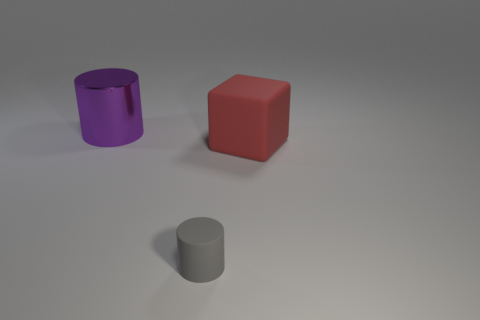Is there any other thing that is the same size as the gray cylinder?
Ensure brevity in your answer.  No. Is there anything else that is the same material as the purple object?
Give a very brief answer. No. What is the shape of the purple metal thing?
Your answer should be compact. Cylinder. Are there any other things that are the same shape as the tiny rubber object?
Your answer should be very brief. Yes. Is the number of small gray rubber cylinders that are on the right side of the large rubber cube less than the number of large yellow balls?
Provide a short and direct response. No. There is a cylinder that is behind the gray matte cylinder; does it have the same color as the small cylinder?
Make the answer very short. No. How many matte objects are either large blue cylinders or tiny cylinders?
Make the answer very short. 1. What color is the tiny object that is the same material as the block?
Provide a succinct answer. Gray. How many cylinders are either tiny blue metal objects or purple shiny things?
Ensure brevity in your answer.  1. What number of things are either green spheres or rubber things in front of the big red matte thing?
Offer a terse response. 1. 